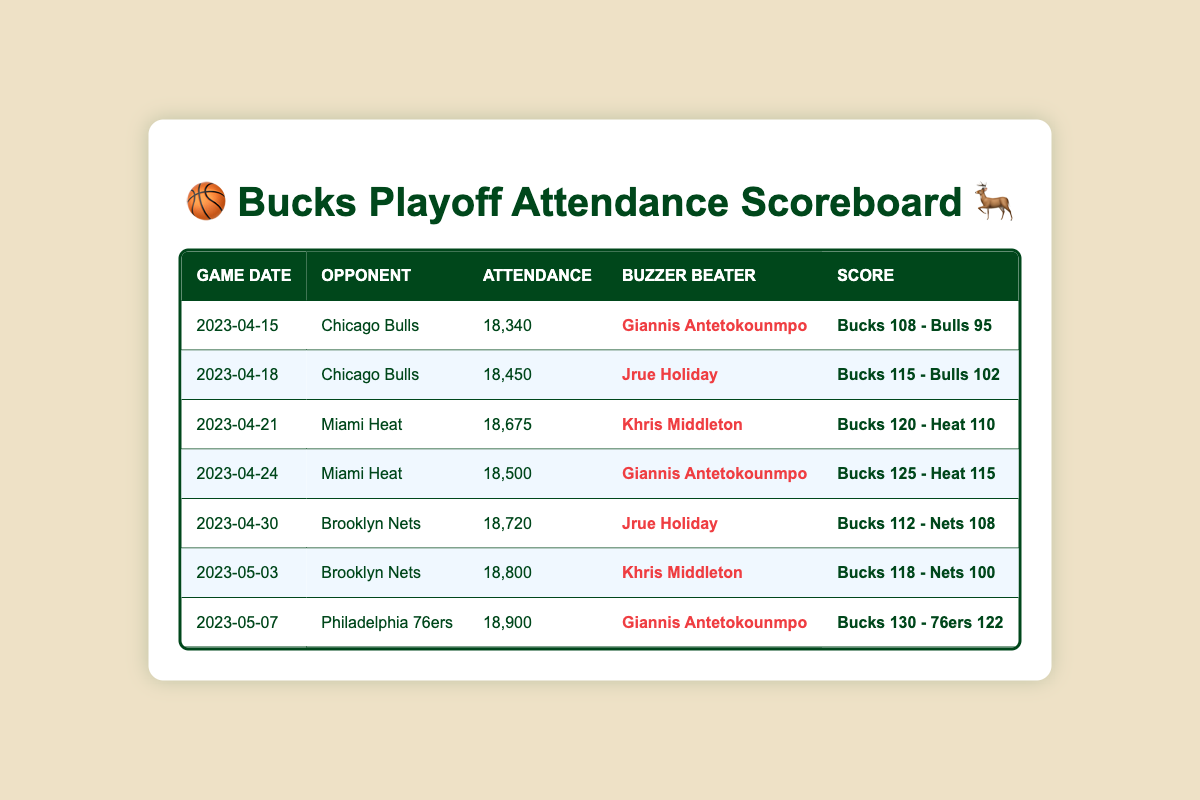What was the attendance count for the game on April 30, 2023? Looking at the table, I find the row for the game on April 30, 2023, against the Brooklyn Nets. The "Attendance" column indicates the attendance count is 18,720.
Answer: 18,720 Which game had the highest attendance? To find the highest attendance, I compare all the attendance counts listed in the table. The highest number is 18,900 for the game against the Philadelphia 76ers on May 7, 2023.
Answer: 18,900 What is the total attendance for all playoff games listed in the table? I add the attendance counts from each game: 18340 + 18450 + 18675 + 18500 + 18720 + 18800 + 18900 = 131,885.
Answer: 131,885 Which game had the lowest attendance and what was the count? I look through the attendance counts and find that the lowest count is 18,340 for the game on April 15, 2023.
Answer: April 15, 2023, and 18,340 Did Giannis Antetokounmpo have the buzzer beater in more than one game? By examining the "Buzzer Beater" column, I see that Giannis is listed as the buzzer beater in the games on April 15, 2023, April 24, 2023, and May 7, 2023. Thus, he had a buzzer beater in three games.
Answer: Yes What is the average attendance for the home games listed? To calculate the average attendance, first sum the attendance counts (131,885) and then divide by the number of games (7): 131885 / 7 = 18,840.71. Therefore, rounding to the nearest integer gives 18,841.
Answer: 18,841 How many games were played against the Miami Heat during this run? I check the table for the number of times the Miami Heat is listed as an opponent. There are two games against the Heat: on April 21 and April 24, 2023.
Answer: 2 Which buzzer beater player scored on the highest attended game? From the table, I identify the highest attendance is 18,900 on May 7, 2023, and the buzzer beater for that game was Giannis Antetokounmpo.
Answer: Giannis Antetokounmpo How many points did the Bucks score in total across all playoff games? I sum the scores from the "Score" column: 108 + 115 + 120 + 125 + 112 + 118 + 130 = 828 points.
Answer: 828 